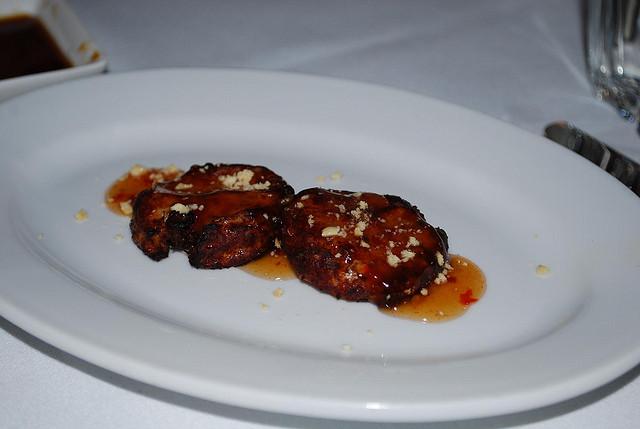How many glasses are in the background?
Keep it brief. 1. Does the food look expensive?
Be succinct. Yes. Are there any vegetables on the plate?
Quick response, please. No. How many items on the plate?
Write a very short answer. 2. Is there broccoli in this meal?
Give a very brief answer. No. What kind of meat in the middle of this dish?
Give a very brief answer. Beef. How many eggs are on the plate?
Short answer required. 0. Is that a meat dish?
Keep it brief. Yes. What shape is the plate?
Keep it brief. Oval. How many items of food are there?
Write a very short answer. 2. 